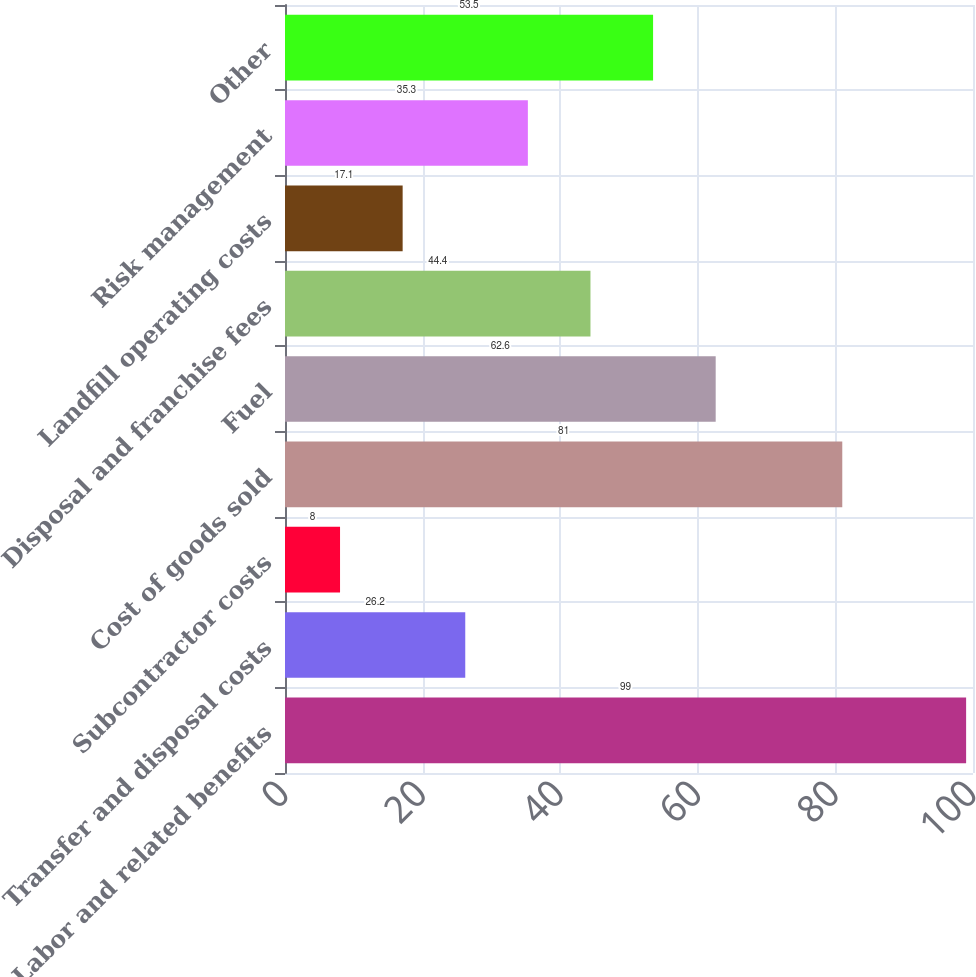<chart> <loc_0><loc_0><loc_500><loc_500><bar_chart><fcel>Labor and related benefits<fcel>Transfer and disposal costs<fcel>Subcontractor costs<fcel>Cost of goods sold<fcel>Fuel<fcel>Disposal and franchise fees<fcel>Landfill operating costs<fcel>Risk management<fcel>Other<nl><fcel>99<fcel>26.2<fcel>8<fcel>81<fcel>62.6<fcel>44.4<fcel>17.1<fcel>35.3<fcel>53.5<nl></chart> 